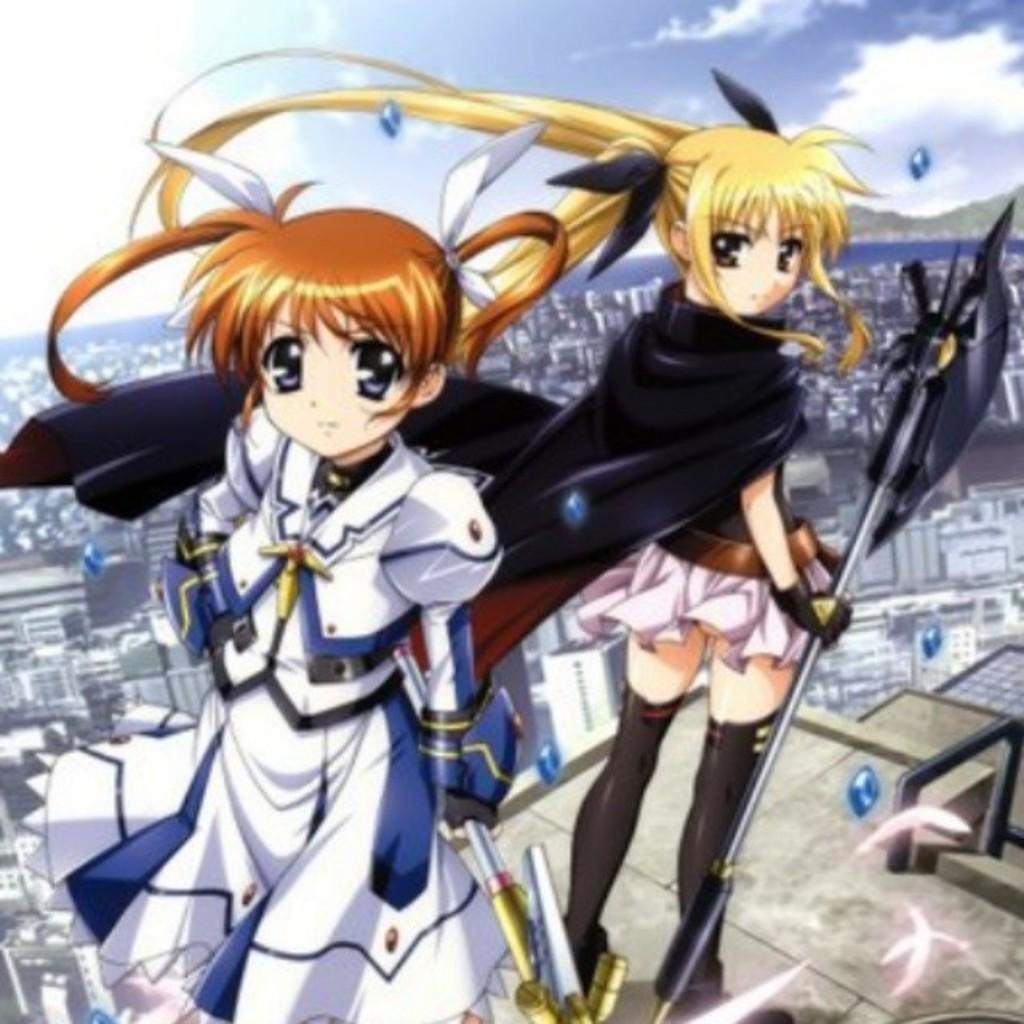Please provide a concise description of this image. This is an animated image where we can see two cartoons. Behind them buildings and sky is there. 